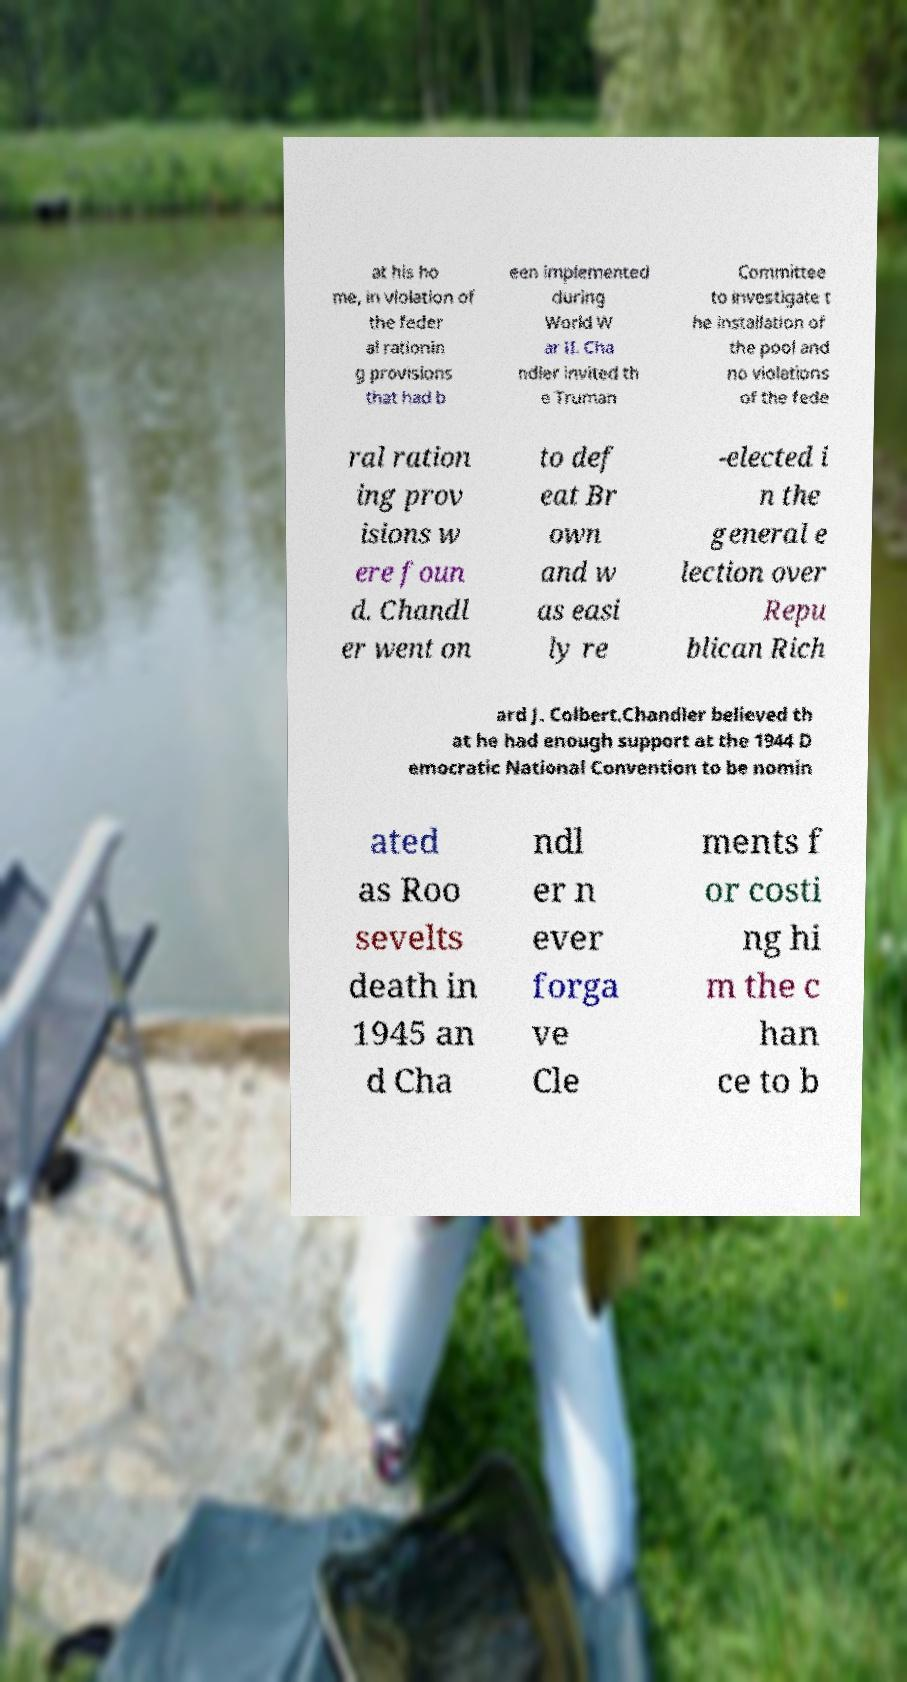Can you read and provide the text displayed in the image?This photo seems to have some interesting text. Can you extract and type it out for me? at his ho me, in violation of the feder al rationin g provisions that had b een implemented during World W ar II. Cha ndler invited th e Truman Committee to investigate t he installation of the pool and no violations of the fede ral ration ing prov isions w ere foun d. Chandl er went on to def eat Br own and w as easi ly re -elected i n the general e lection over Repu blican Rich ard J. Colbert.Chandler believed th at he had enough support at the 1944 D emocratic National Convention to be nomin ated as Roo sevelts death in 1945 an d Cha ndl er n ever forga ve Cle ments f or costi ng hi m the c han ce to b 